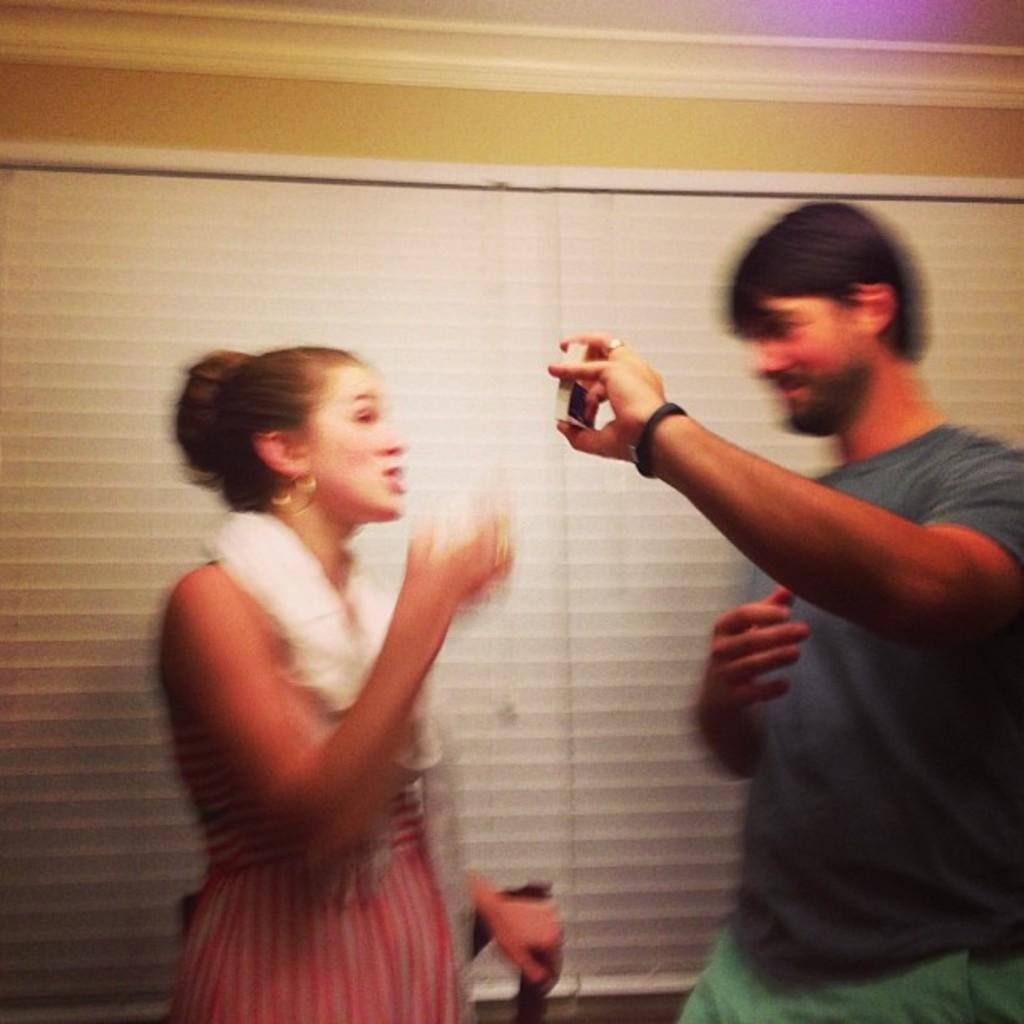What is the man doing in the image? The man is holding an object in the image. Who else is present in the image? There is a woman standing in the image. What can be seen in the background of the image? There is a wall, a window, and a mat near the window in the background of the image. What is visible at the top of the image? The ceiling is visible at the top of the image. What type of humor can be seen in the image? There is no humor present in the image; it is a straightforward depiction of a man holding an object and a woman standing nearby. How does the motion of the objects in the image affect the overall composition? There is no motion present in the image, as both the man and the woman are standing still. 